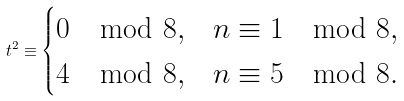<formula> <loc_0><loc_0><loc_500><loc_500>t ^ { 2 } \equiv \begin{cases} 0 \mod 8 , & n \equiv 1 \mod 8 , \\ 4 \mod 8 , & n \equiv 5 \mod 8 . \end{cases}</formula> 